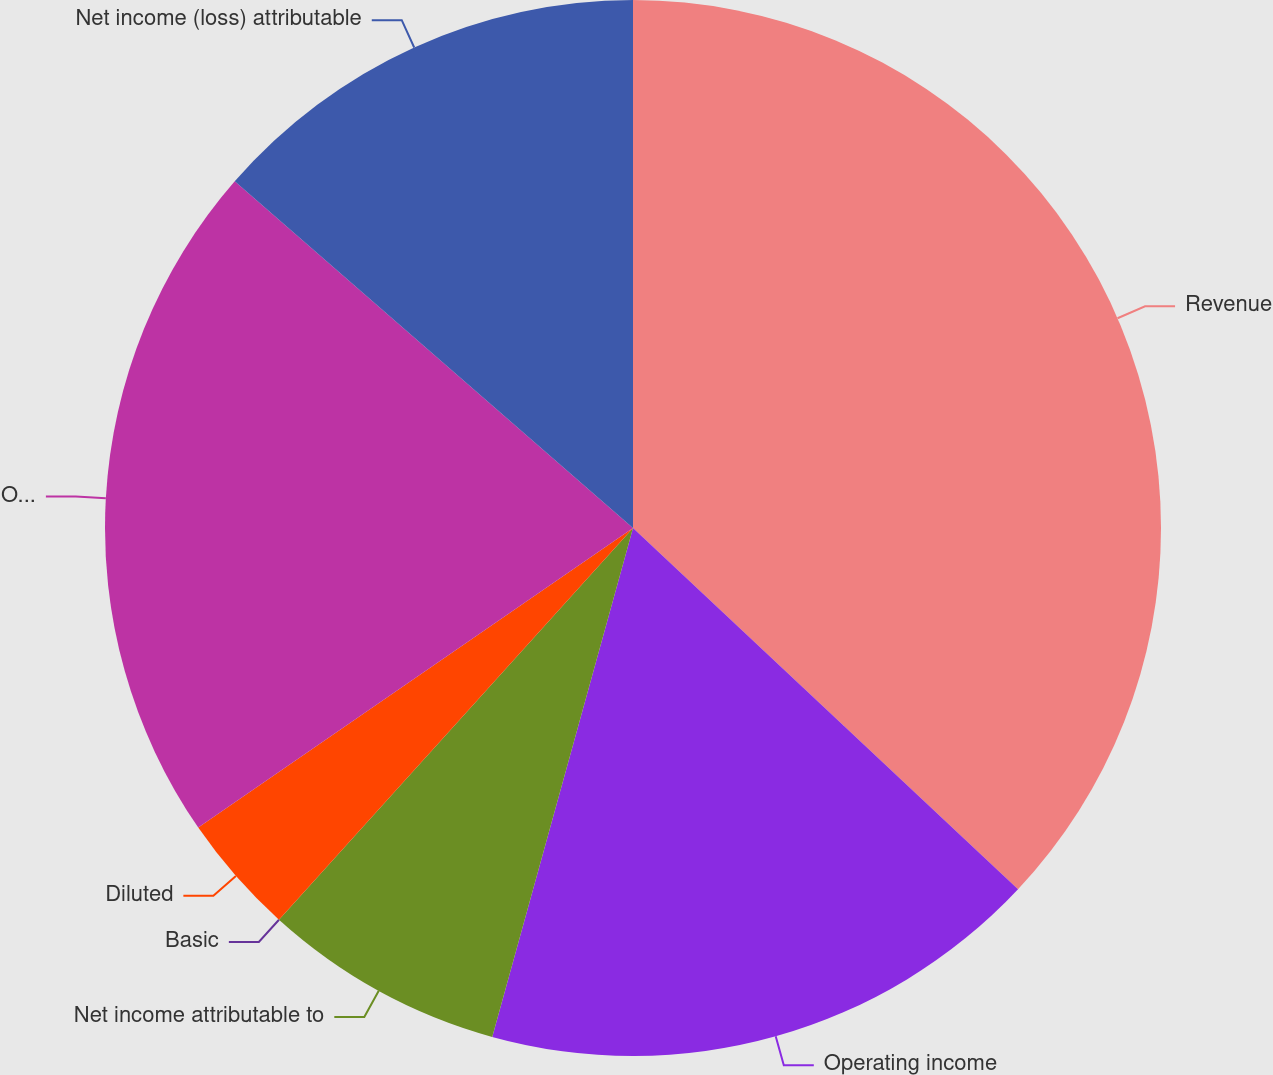Convert chart. <chart><loc_0><loc_0><loc_500><loc_500><pie_chart><fcel>Revenue<fcel>Operating income<fcel>Net income attributable to<fcel>Basic<fcel>Diluted<fcel>Operating income (loss)<fcel>Net income (loss) attributable<nl><fcel>36.99%<fcel>17.3%<fcel>7.4%<fcel>0.0%<fcel>3.7%<fcel>21.0%<fcel>13.6%<nl></chart> 